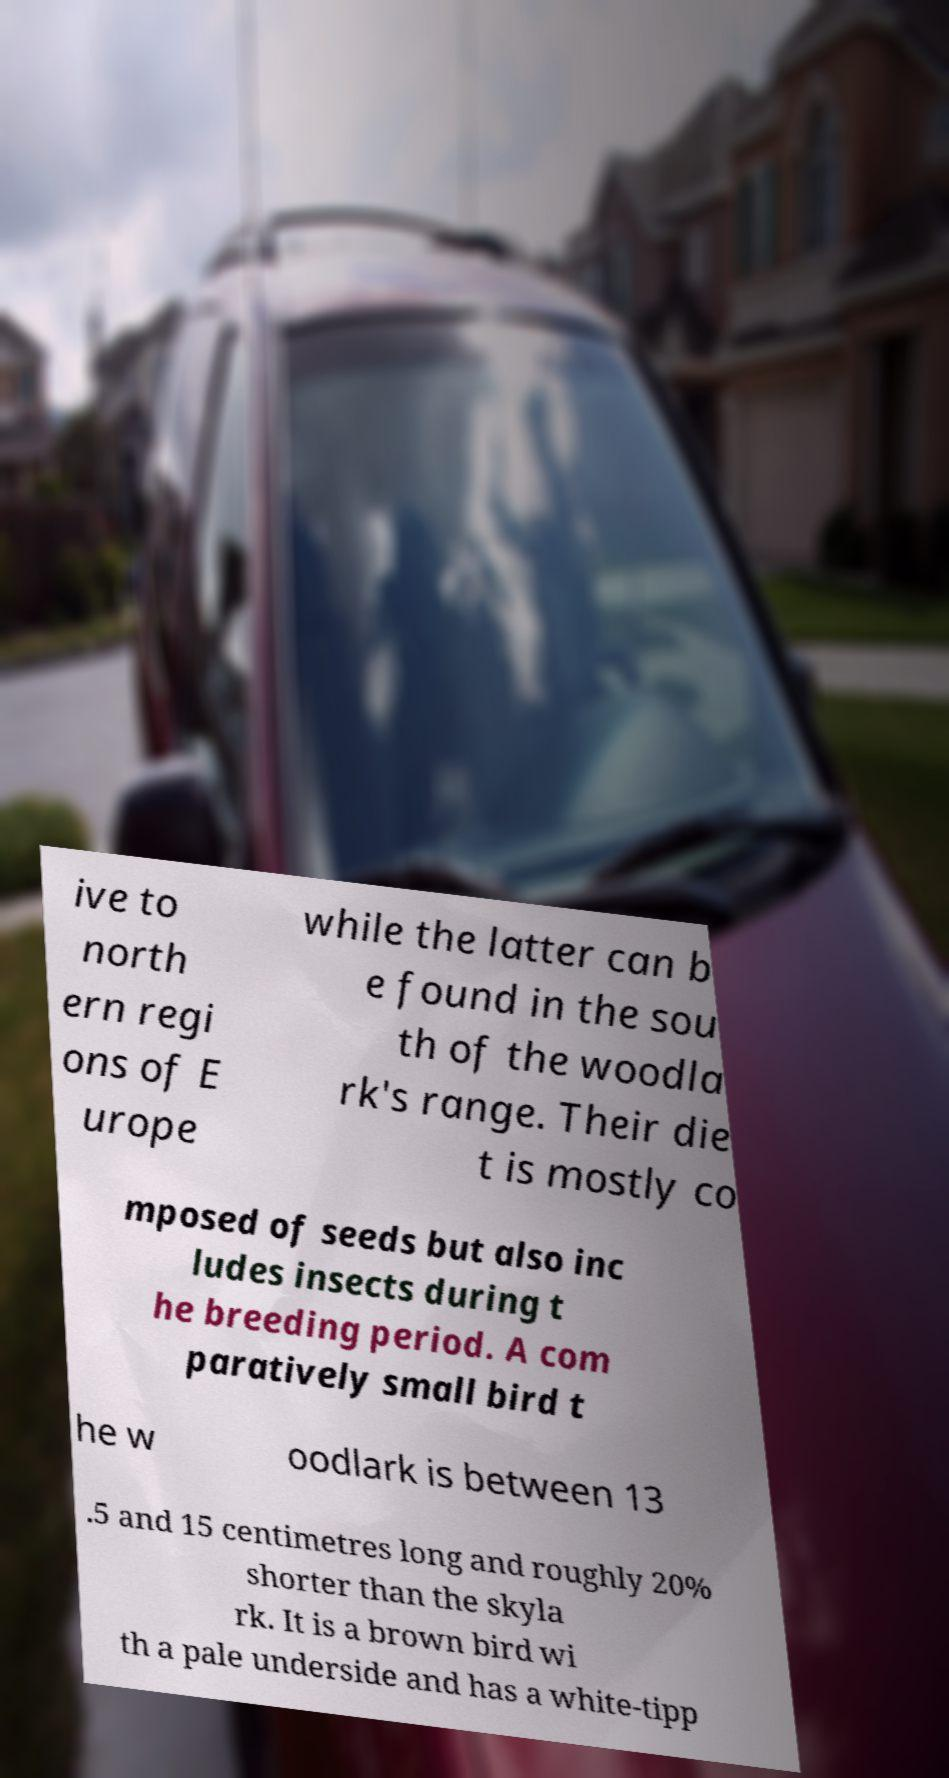Could you assist in decoding the text presented in this image and type it out clearly? ive to north ern regi ons of E urope while the latter can b e found in the sou th of the woodla rk's range. Their die t is mostly co mposed of seeds but also inc ludes insects during t he breeding period. A com paratively small bird t he w oodlark is between 13 .5 and 15 centimetres long and roughly 20% shorter than the skyla rk. It is a brown bird wi th a pale underside and has a white-tipp 